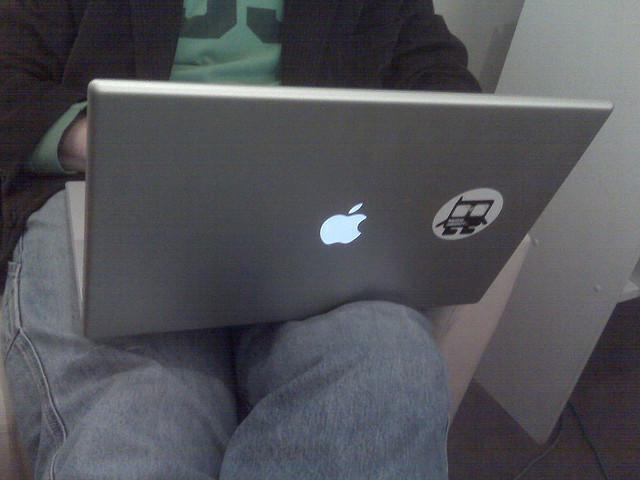How many laptops are there?
Give a very brief answer. 1. How many cows a man is holding?
Give a very brief answer. 0. 